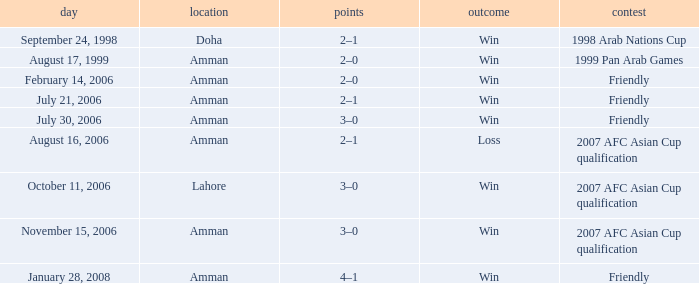Where did Ra'fat Ali play on August 17, 1999? Amman. 